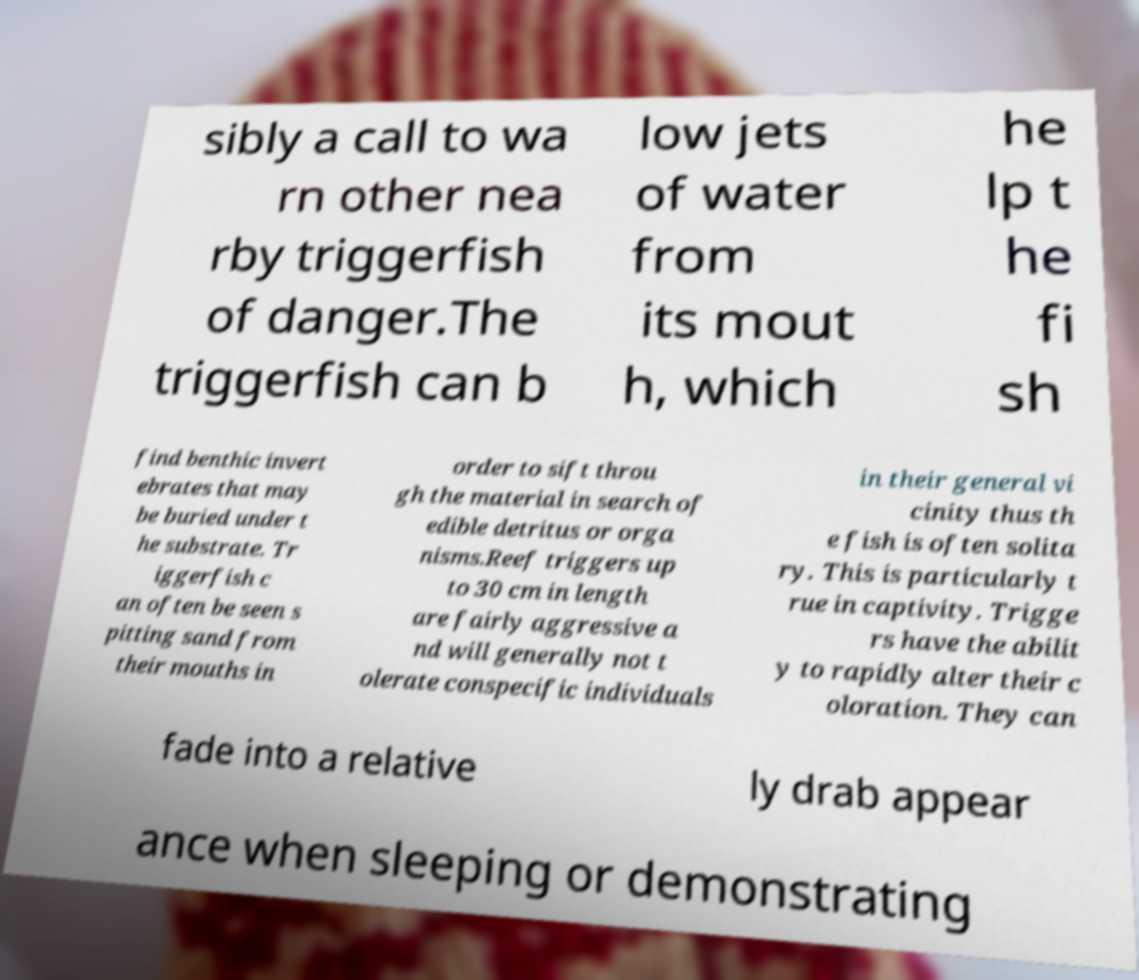What messages or text are displayed in this image? I need them in a readable, typed format. sibly a call to wa rn other nea rby triggerfish of danger.The triggerfish can b low jets of water from its mout h, which he lp t he fi sh find benthic invert ebrates that may be buried under t he substrate. Tr iggerfish c an often be seen s pitting sand from their mouths in order to sift throu gh the material in search of edible detritus or orga nisms.Reef triggers up to 30 cm in length are fairly aggressive a nd will generally not t olerate conspecific individuals in their general vi cinity thus th e fish is often solita ry. This is particularly t rue in captivity. Trigge rs have the abilit y to rapidly alter their c oloration. They can fade into a relative ly drab appear ance when sleeping or demonstrating 